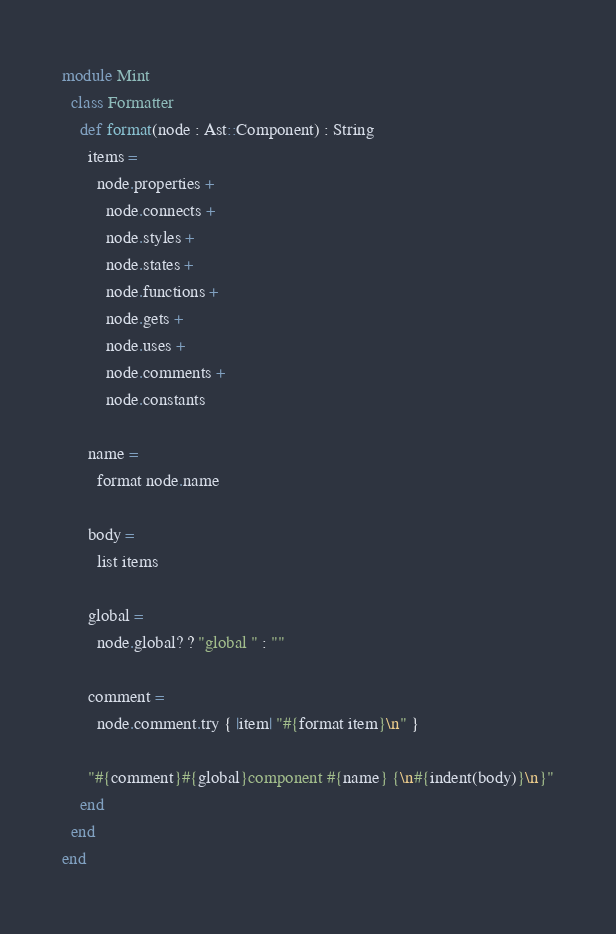Convert code to text. <code><loc_0><loc_0><loc_500><loc_500><_Crystal_>module Mint
  class Formatter
    def format(node : Ast::Component) : String
      items =
        node.properties +
          node.connects +
          node.styles +
          node.states +
          node.functions +
          node.gets +
          node.uses +
          node.comments +
          node.constants

      name =
        format node.name

      body =
        list items

      global =
        node.global? ? "global " : ""

      comment =
        node.comment.try { |item| "#{format item}\n" }

      "#{comment}#{global}component #{name} {\n#{indent(body)}\n}"
    end
  end
end
</code> 